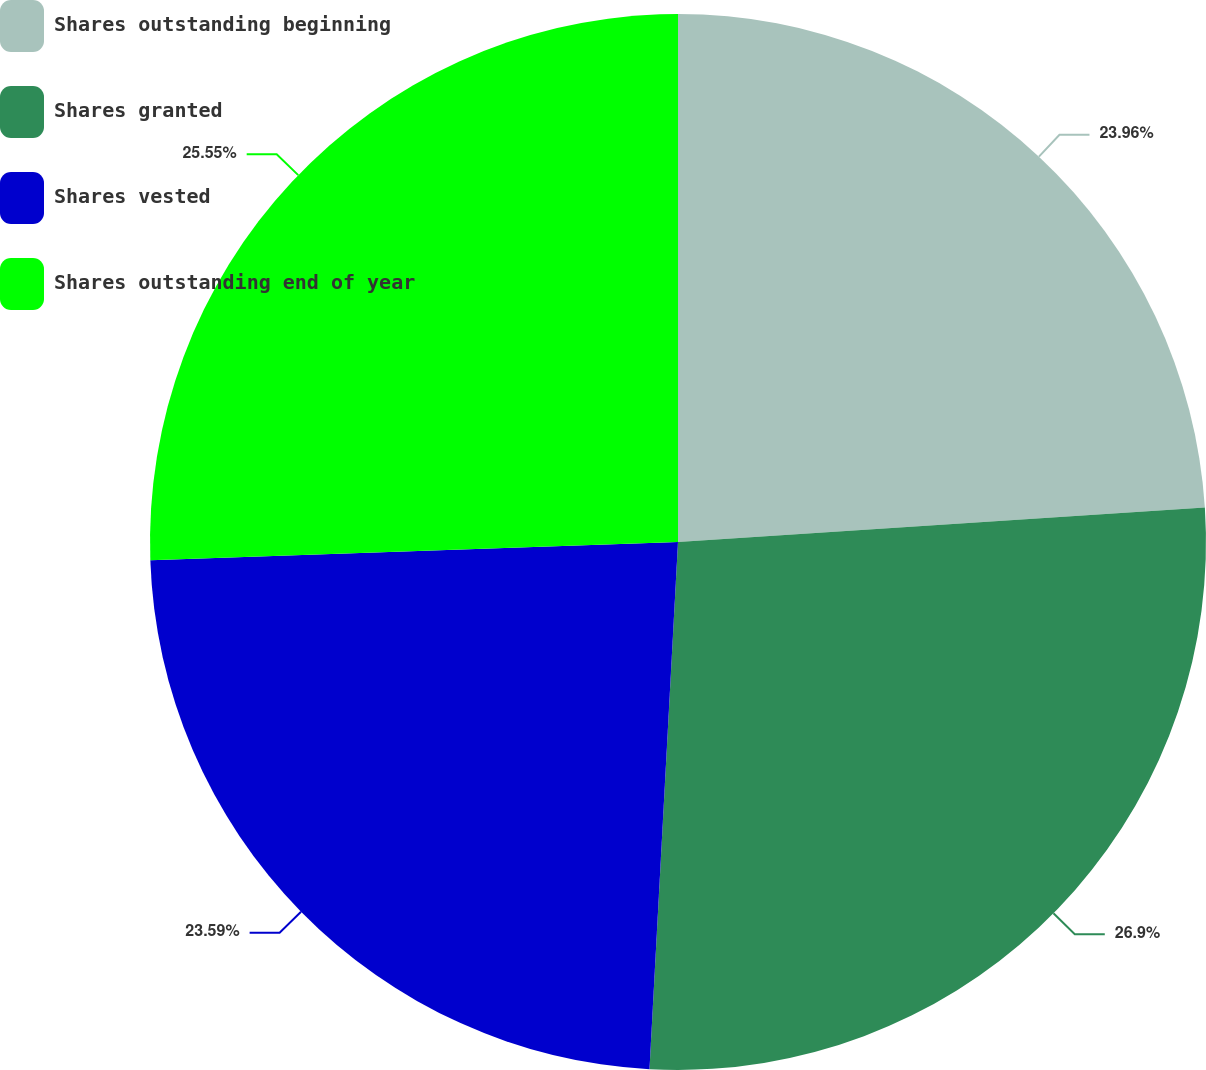Convert chart to OTSL. <chart><loc_0><loc_0><loc_500><loc_500><pie_chart><fcel>Shares outstanding beginning<fcel>Shares granted<fcel>Shares vested<fcel>Shares outstanding end of year<nl><fcel>23.96%<fcel>26.9%<fcel>23.59%<fcel>25.55%<nl></chart> 